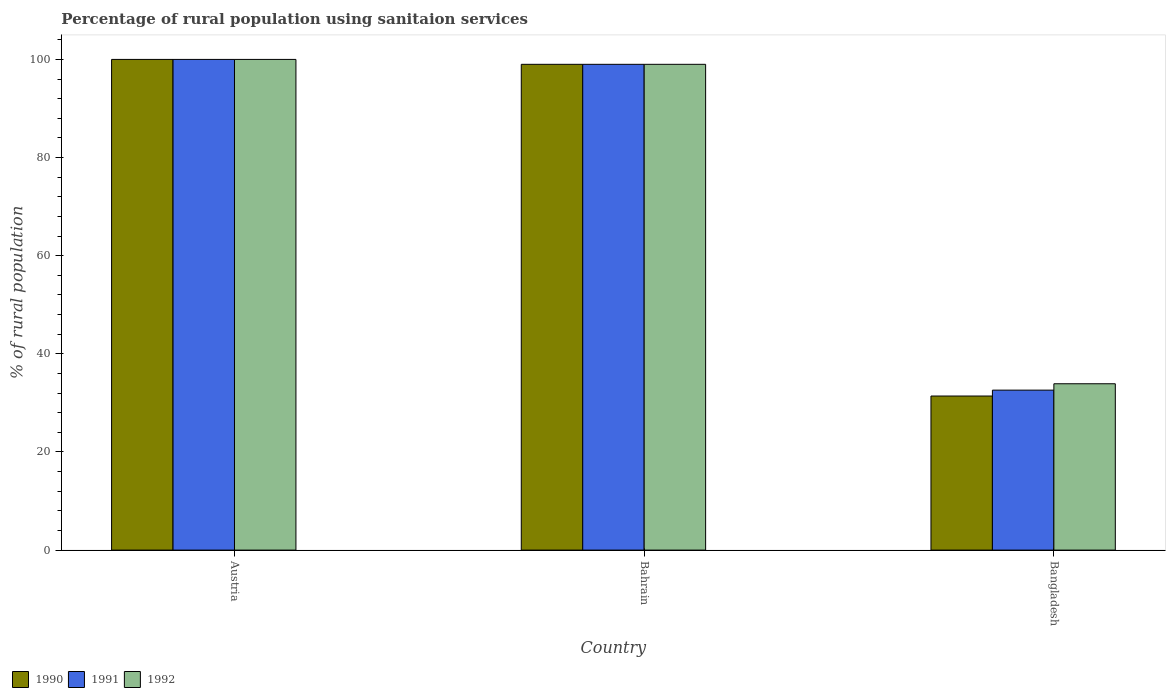How many groups of bars are there?
Make the answer very short. 3. How many bars are there on the 1st tick from the left?
Provide a short and direct response. 3. What is the label of the 1st group of bars from the left?
Make the answer very short. Austria. In how many cases, is the number of bars for a given country not equal to the number of legend labels?
Your response must be concise. 0. What is the percentage of rural population using sanitaion services in 1991 in Bahrain?
Offer a very short reply. 99. Across all countries, what is the maximum percentage of rural population using sanitaion services in 1990?
Provide a succinct answer. 100. Across all countries, what is the minimum percentage of rural population using sanitaion services in 1990?
Your response must be concise. 31.4. In which country was the percentage of rural population using sanitaion services in 1991 minimum?
Offer a terse response. Bangladesh. What is the total percentage of rural population using sanitaion services in 1991 in the graph?
Provide a succinct answer. 231.6. What is the difference between the percentage of rural population using sanitaion services in 1991 in Bahrain and that in Bangladesh?
Ensure brevity in your answer.  66.4. What is the average percentage of rural population using sanitaion services in 1992 per country?
Offer a very short reply. 77.63. In how many countries, is the percentage of rural population using sanitaion services in 1991 greater than 60 %?
Provide a short and direct response. 2. What is the ratio of the percentage of rural population using sanitaion services in 1991 in Austria to that in Bangladesh?
Provide a short and direct response. 3.07. What is the difference between the highest and the second highest percentage of rural population using sanitaion services in 1992?
Make the answer very short. -65.1. What is the difference between the highest and the lowest percentage of rural population using sanitaion services in 1991?
Ensure brevity in your answer.  67.4. How many countries are there in the graph?
Your answer should be compact. 3. Does the graph contain grids?
Keep it short and to the point. No. How are the legend labels stacked?
Your response must be concise. Horizontal. What is the title of the graph?
Offer a very short reply. Percentage of rural population using sanitaion services. What is the label or title of the Y-axis?
Provide a short and direct response. % of rural population. What is the % of rural population of 1990 in Austria?
Your answer should be compact. 100. What is the % of rural population in 1992 in Austria?
Provide a succinct answer. 100. What is the % of rural population of 1990 in Bahrain?
Your response must be concise. 99. What is the % of rural population of 1992 in Bahrain?
Ensure brevity in your answer.  99. What is the % of rural population of 1990 in Bangladesh?
Provide a short and direct response. 31.4. What is the % of rural population of 1991 in Bangladesh?
Your answer should be very brief. 32.6. What is the % of rural population in 1992 in Bangladesh?
Your response must be concise. 33.9. Across all countries, what is the maximum % of rural population in 1990?
Provide a short and direct response. 100. Across all countries, what is the maximum % of rural population in 1991?
Ensure brevity in your answer.  100. Across all countries, what is the maximum % of rural population of 1992?
Give a very brief answer. 100. Across all countries, what is the minimum % of rural population in 1990?
Your answer should be compact. 31.4. Across all countries, what is the minimum % of rural population in 1991?
Give a very brief answer. 32.6. Across all countries, what is the minimum % of rural population in 1992?
Provide a short and direct response. 33.9. What is the total % of rural population of 1990 in the graph?
Provide a succinct answer. 230.4. What is the total % of rural population of 1991 in the graph?
Offer a very short reply. 231.6. What is the total % of rural population of 1992 in the graph?
Keep it short and to the point. 232.9. What is the difference between the % of rural population of 1990 in Austria and that in Bangladesh?
Keep it short and to the point. 68.6. What is the difference between the % of rural population of 1991 in Austria and that in Bangladesh?
Your response must be concise. 67.4. What is the difference between the % of rural population in 1992 in Austria and that in Bangladesh?
Keep it short and to the point. 66.1. What is the difference between the % of rural population of 1990 in Bahrain and that in Bangladesh?
Ensure brevity in your answer.  67.6. What is the difference between the % of rural population of 1991 in Bahrain and that in Bangladesh?
Ensure brevity in your answer.  66.4. What is the difference between the % of rural population of 1992 in Bahrain and that in Bangladesh?
Keep it short and to the point. 65.1. What is the difference between the % of rural population in 1990 in Austria and the % of rural population in 1992 in Bahrain?
Provide a short and direct response. 1. What is the difference between the % of rural population of 1991 in Austria and the % of rural population of 1992 in Bahrain?
Your response must be concise. 1. What is the difference between the % of rural population in 1990 in Austria and the % of rural population in 1991 in Bangladesh?
Ensure brevity in your answer.  67.4. What is the difference between the % of rural population in 1990 in Austria and the % of rural population in 1992 in Bangladesh?
Offer a very short reply. 66.1. What is the difference between the % of rural population of 1991 in Austria and the % of rural population of 1992 in Bangladesh?
Your answer should be very brief. 66.1. What is the difference between the % of rural population in 1990 in Bahrain and the % of rural population in 1991 in Bangladesh?
Offer a very short reply. 66.4. What is the difference between the % of rural population of 1990 in Bahrain and the % of rural population of 1992 in Bangladesh?
Ensure brevity in your answer.  65.1. What is the difference between the % of rural population in 1991 in Bahrain and the % of rural population in 1992 in Bangladesh?
Offer a very short reply. 65.1. What is the average % of rural population of 1990 per country?
Provide a short and direct response. 76.8. What is the average % of rural population of 1991 per country?
Provide a short and direct response. 77.2. What is the average % of rural population of 1992 per country?
Your response must be concise. 77.63. What is the difference between the % of rural population of 1990 and % of rural population of 1991 in Austria?
Your response must be concise. 0. What is the difference between the % of rural population of 1990 and % of rural population of 1991 in Bangladesh?
Make the answer very short. -1.2. What is the difference between the % of rural population in 1991 and % of rural population in 1992 in Bangladesh?
Make the answer very short. -1.3. What is the ratio of the % of rural population in 1991 in Austria to that in Bahrain?
Keep it short and to the point. 1.01. What is the ratio of the % of rural population in 1992 in Austria to that in Bahrain?
Your answer should be compact. 1.01. What is the ratio of the % of rural population of 1990 in Austria to that in Bangladesh?
Give a very brief answer. 3.18. What is the ratio of the % of rural population in 1991 in Austria to that in Bangladesh?
Your answer should be compact. 3.07. What is the ratio of the % of rural population in 1992 in Austria to that in Bangladesh?
Offer a very short reply. 2.95. What is the ratio of the % of rural population in 1990 in Bahrain to that in Bangladesh?
Offer a very short reply. 3.15. What is the ratio of the % of rural population of 1991 in Bahrain to that in Bangladesh?
Give a very brief answer. 3.04. What is the ratio of the % of rural population of 1992 in Bahrain to that in Bangladesh?
Provide a short and direct response. 2.92. What is the difference between the highest and the second highest % of rural population in 1990?
Offer a very short reply. 1. What is the difference between the highest and the lowest % of rural population of 1990?
Make the answer very short. 68.6. What is the difference between the highest and the lowest % of rural population of 1991?
Your response must be concise. 67.4. What is the difference between the highest and the lowest % of rural population of 1992?
Your answer should be compact. 66.1. 